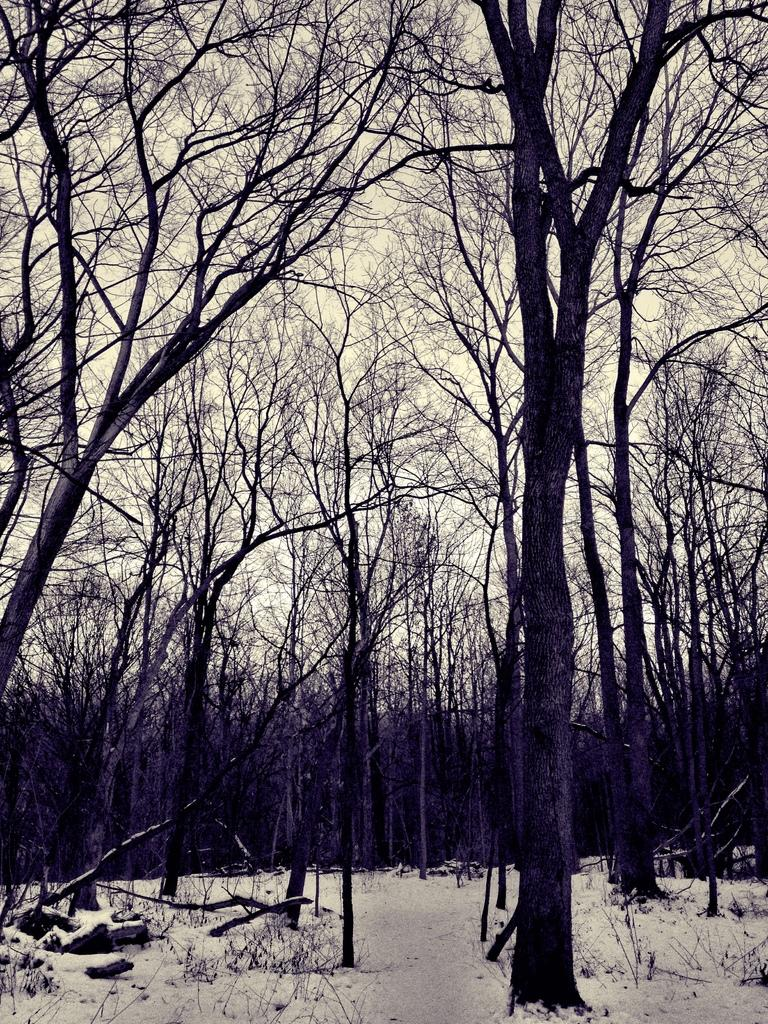What type of vegetation can be seen in the image? There are trees in the image. What natural element is visible in the image? Ice is visible in the image. What part of the natural environment is visible in the image? The sky is visible in the image. What type of suit is the tree wearing in the image? There is no suit present in the image, as trees are not capable of wearing clothing. How does friction affect the ice in the image? There is no information about friction or its effects on the ice in the image. 